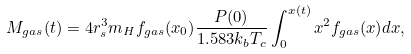Convert formula to latex. <formula><loc_0><loc_0><loc_500><loc_500>M _ { g a s } ( t ) = 4 r _ { s } ^ { 3 } m _ { H } f _ { g a s } ( x _ { 0 } ) \frac { P ( 0 ) } { 1 . 5 8 3 k _ { b } T _ { c } } \int ^ { x ( t ) } _ { 0 } x ^ { 2 } f _ { g a s } ( x ) d x ,</formula> 